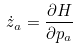Convert formula to latex. <formula><loc_0><loc_0><loc_500><loc_500>\dot { z } _ { a } = \frac { \partial H } { \partial p _ { a } }</formula> 